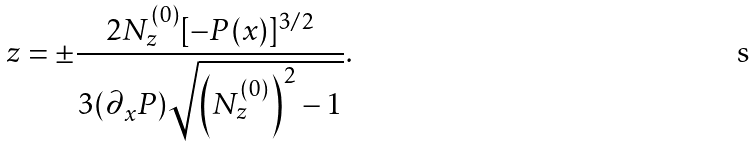<formula> <loc_0><loc_0><loc_500><loc_500>z = \pm \frac { 2 N _ { z } ^ { ( 0 ) } [ - P ( x ) ] ^ { 3 / 2 } } { 3 ( \partial _ { x } P ) \sqrt { { \left ( N _ { z } ^ { ( 0 ) } \right ) } ^ { 2 } - 1 } } .</formula> 